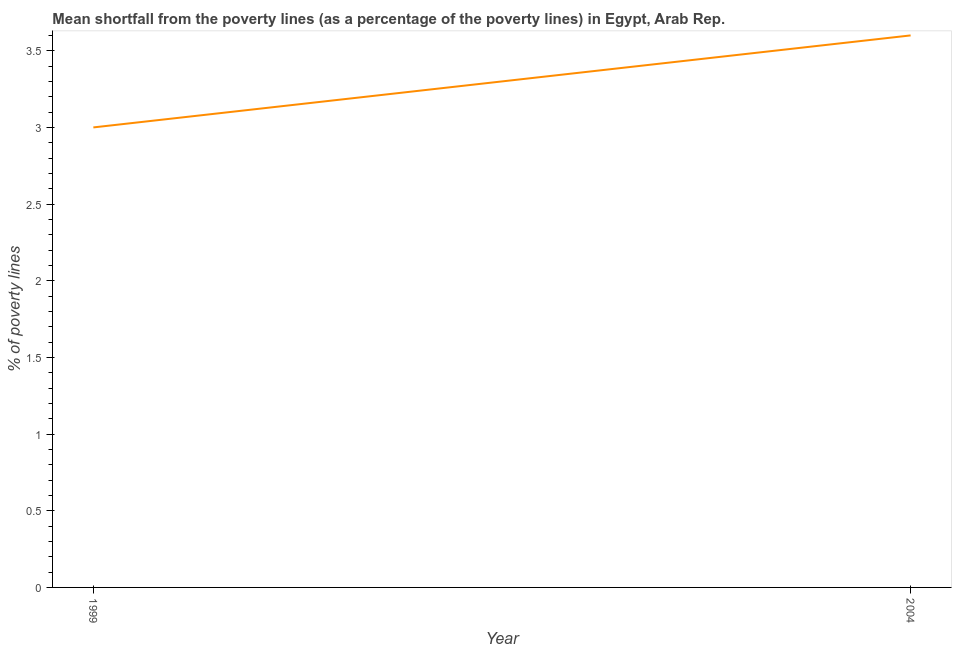What is the poverty gap at national poverty lines in 2004?
Your answer should be very brief. 3.6. Across all years, what is the maximum poverty gap at national poverty lines?
Offer a very short reply. 3.6. Across all years, what is the minimum poverty gap at national poverty lines?
Offer a terse response. 3. In which year was the poverty gap at national poverty lines maximum?
Offer a very short reply. 2004. What is the sum of the poverty gap at national poverty lines?
Ensure brevity in your answer.  6.6. What is the difference between the poverty gap at national poverty lines in 1999 and 2004?
Your response must be concise. -0.6. Do a majority of the years between 1999 and 2004 (inclusive) have poverty gap at national poverty lines greater than 3.1 %?
Offer a terse response. No. What is the ratio of the poverty gap at national poverty lines in 1999 to that in 2004?
Your answer should be compact. 0.83. Is the poverty gap at national poverty lines in 1999 less than that in 2004?
Your answer should be very brief. Yes. In how many years, is the poverty gap at national poverty lines greater than the average poverty gap at national poverty lines taken over all years?
Offer a terse response. 1. How many lines are there?
Offer a terse response. 1. What is the difference between two consecutive major ticks on the Y-axis?
Make the answer very short. 0.5. What is the title of the graph?
Give a very brief answer. Mean shortfall from the poverty lines (as a percentage of the poverty lines) in Egypt, Arab Rep. What is the label or title of the Y-axis?
Provide a succinct answer. % of poverty lines. What is the % of poverty lines of 2004?
Your answer should be compact. 3.6. What is the ratio of the % of poverty lines in 1999 to that in 2004?
Your answer should be compact. 0.83. 